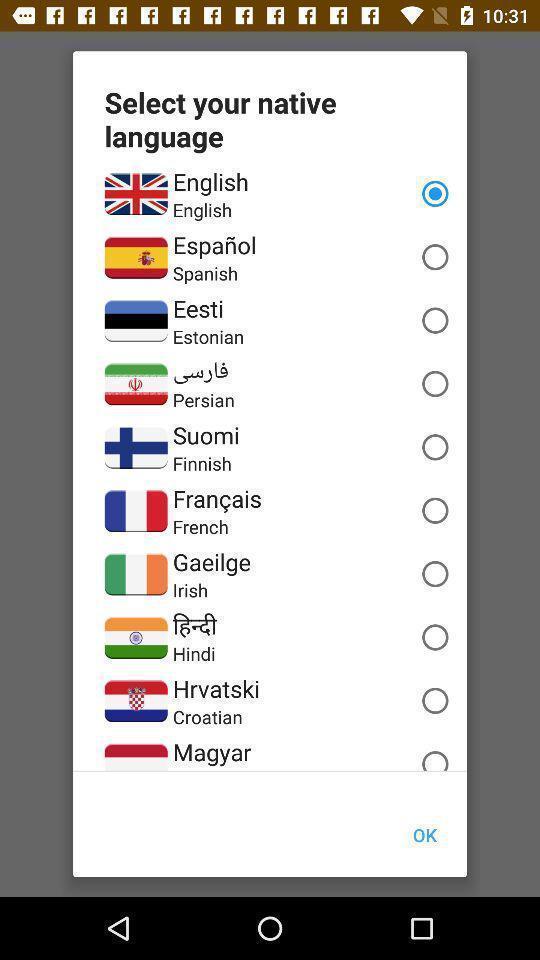What details can you identify in this image? Pop up list for selecting different languages. 